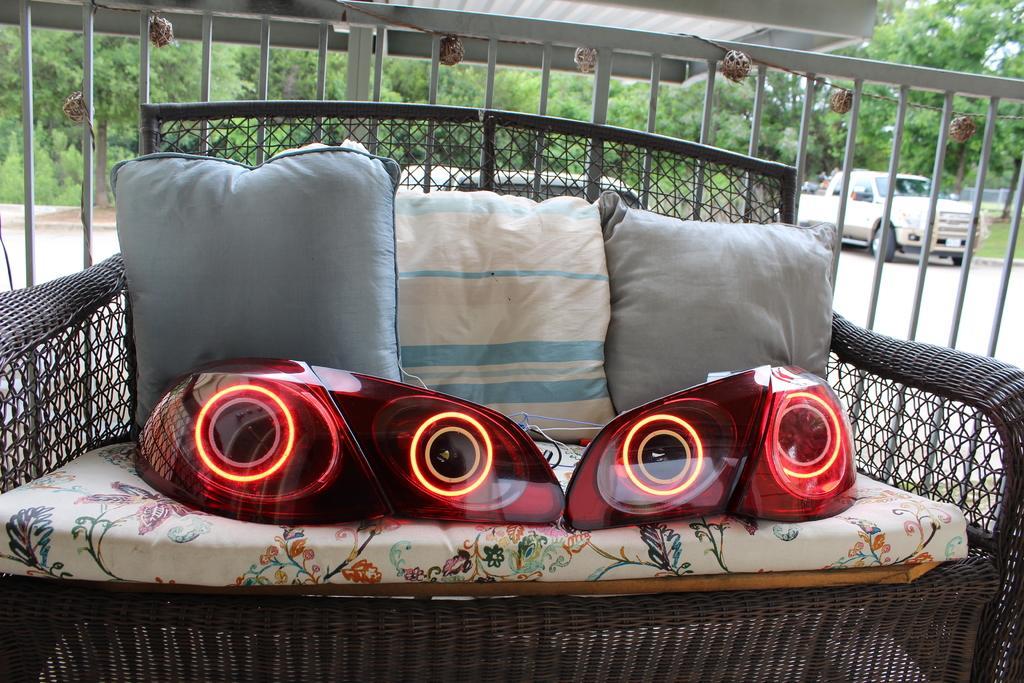Describe this image in one or two sentences. In the image I can see pillows and other objects on a sofa. In the background I can see vehicles, trees, the grass and some other objects. 